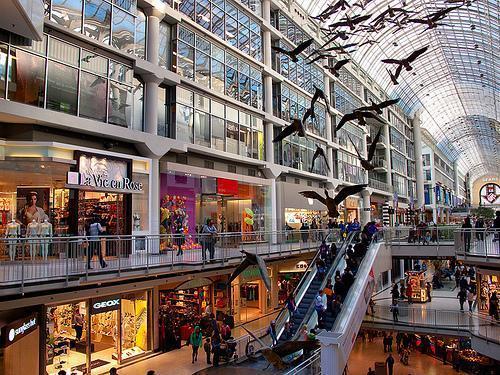How many levels of the mall are there?
Give a very brief answer. 3. How many escalators are there?
Give a very brief answer. 2. 